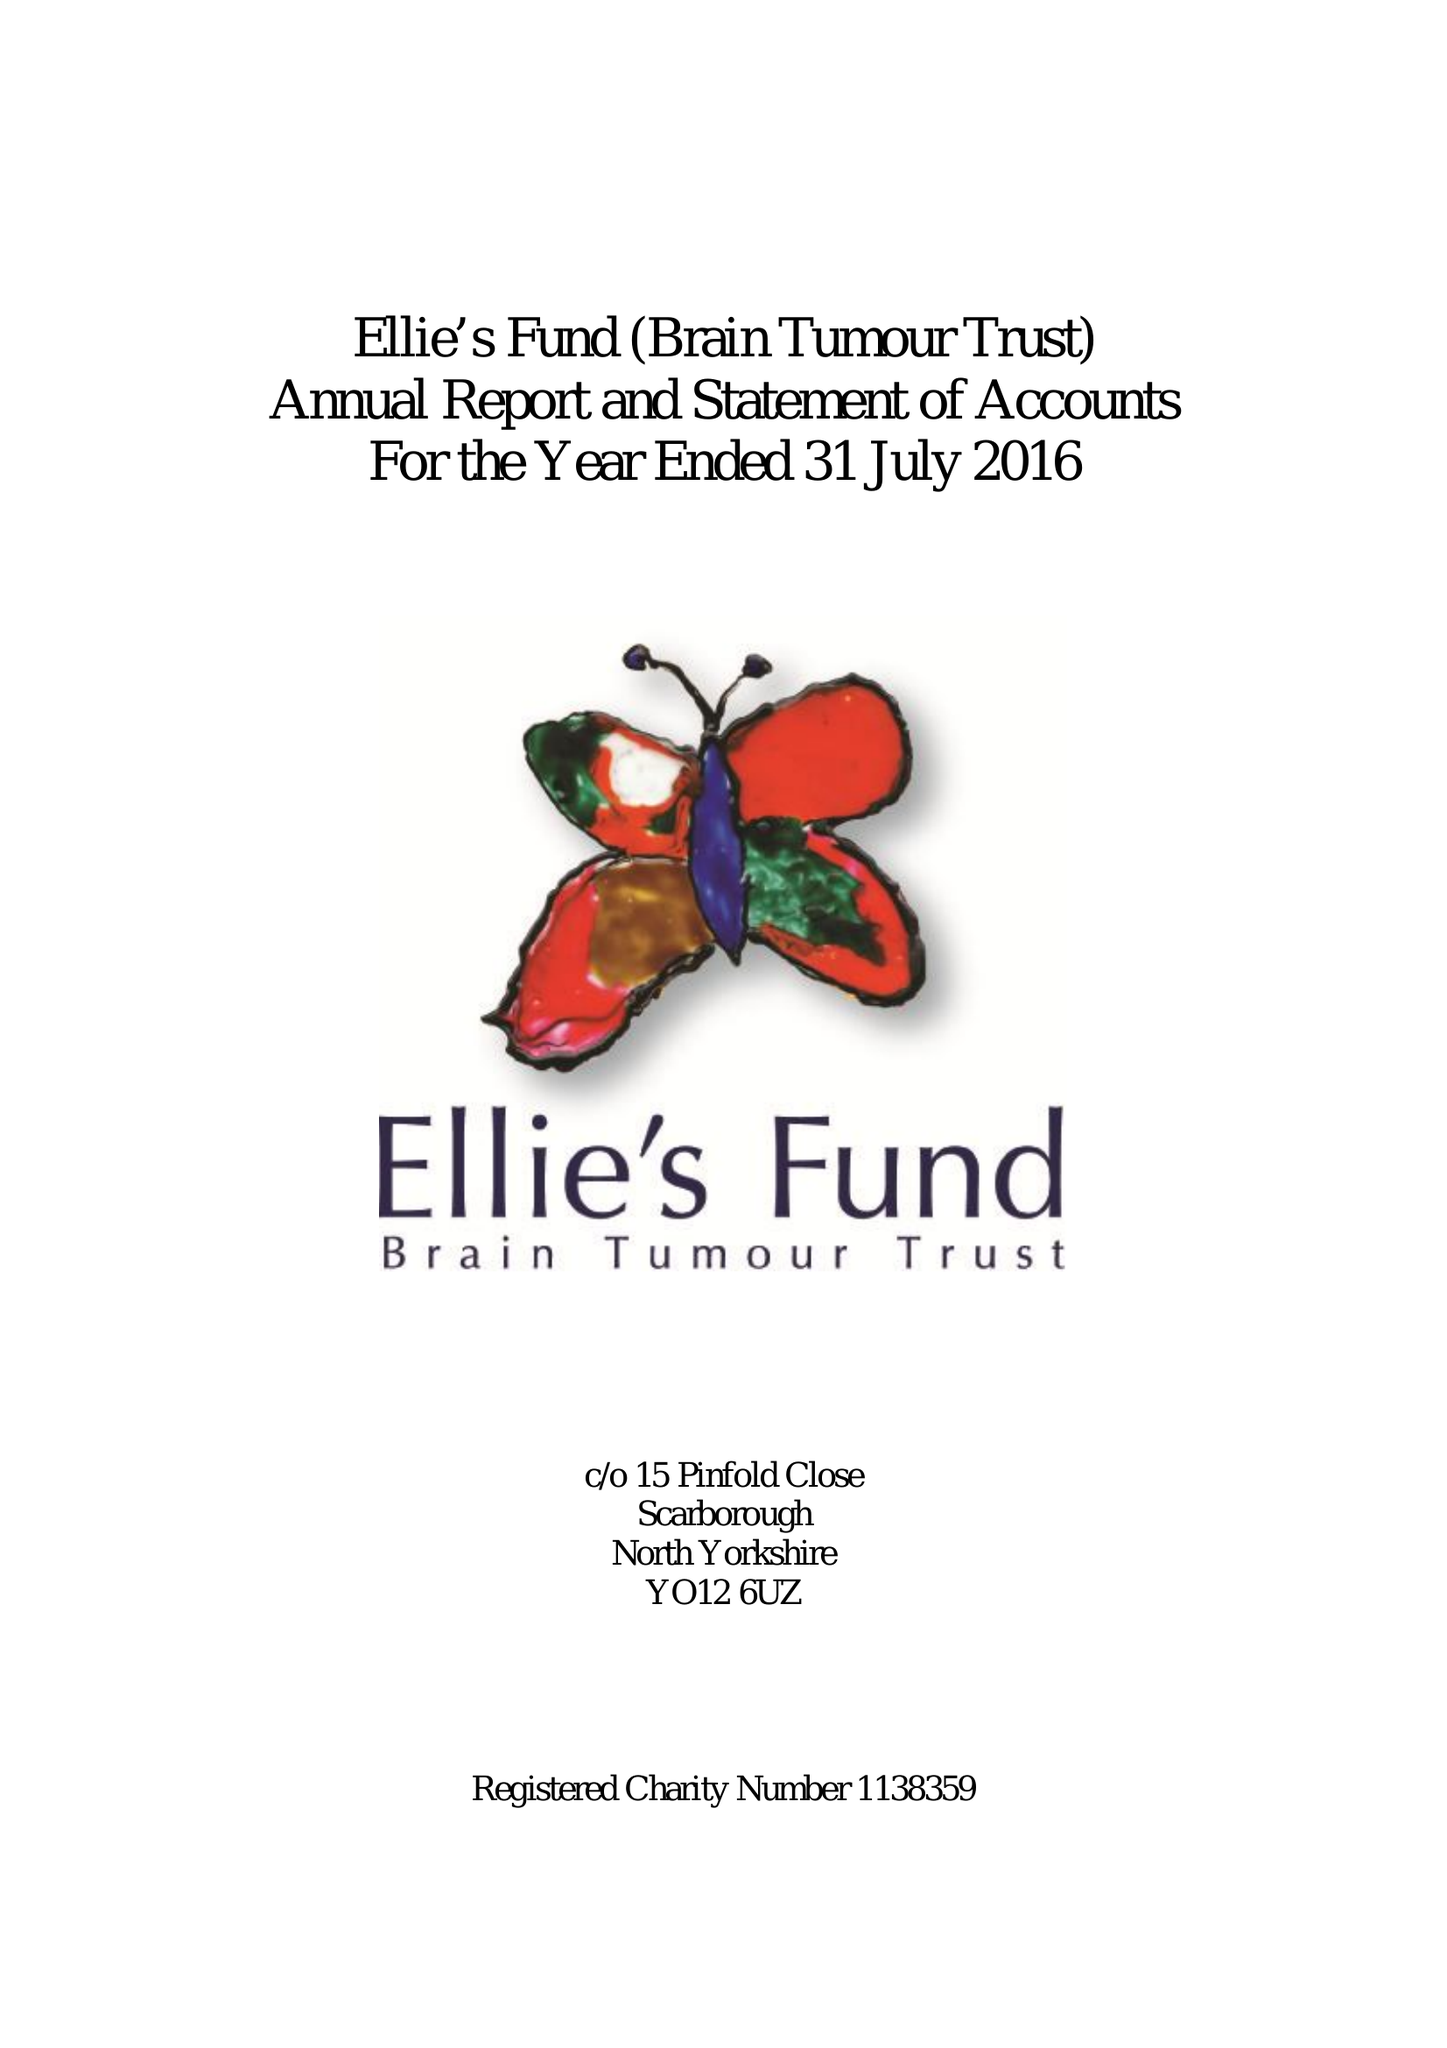What is the value for the address__street_line?
Answer the question using a single word or phrase. None 